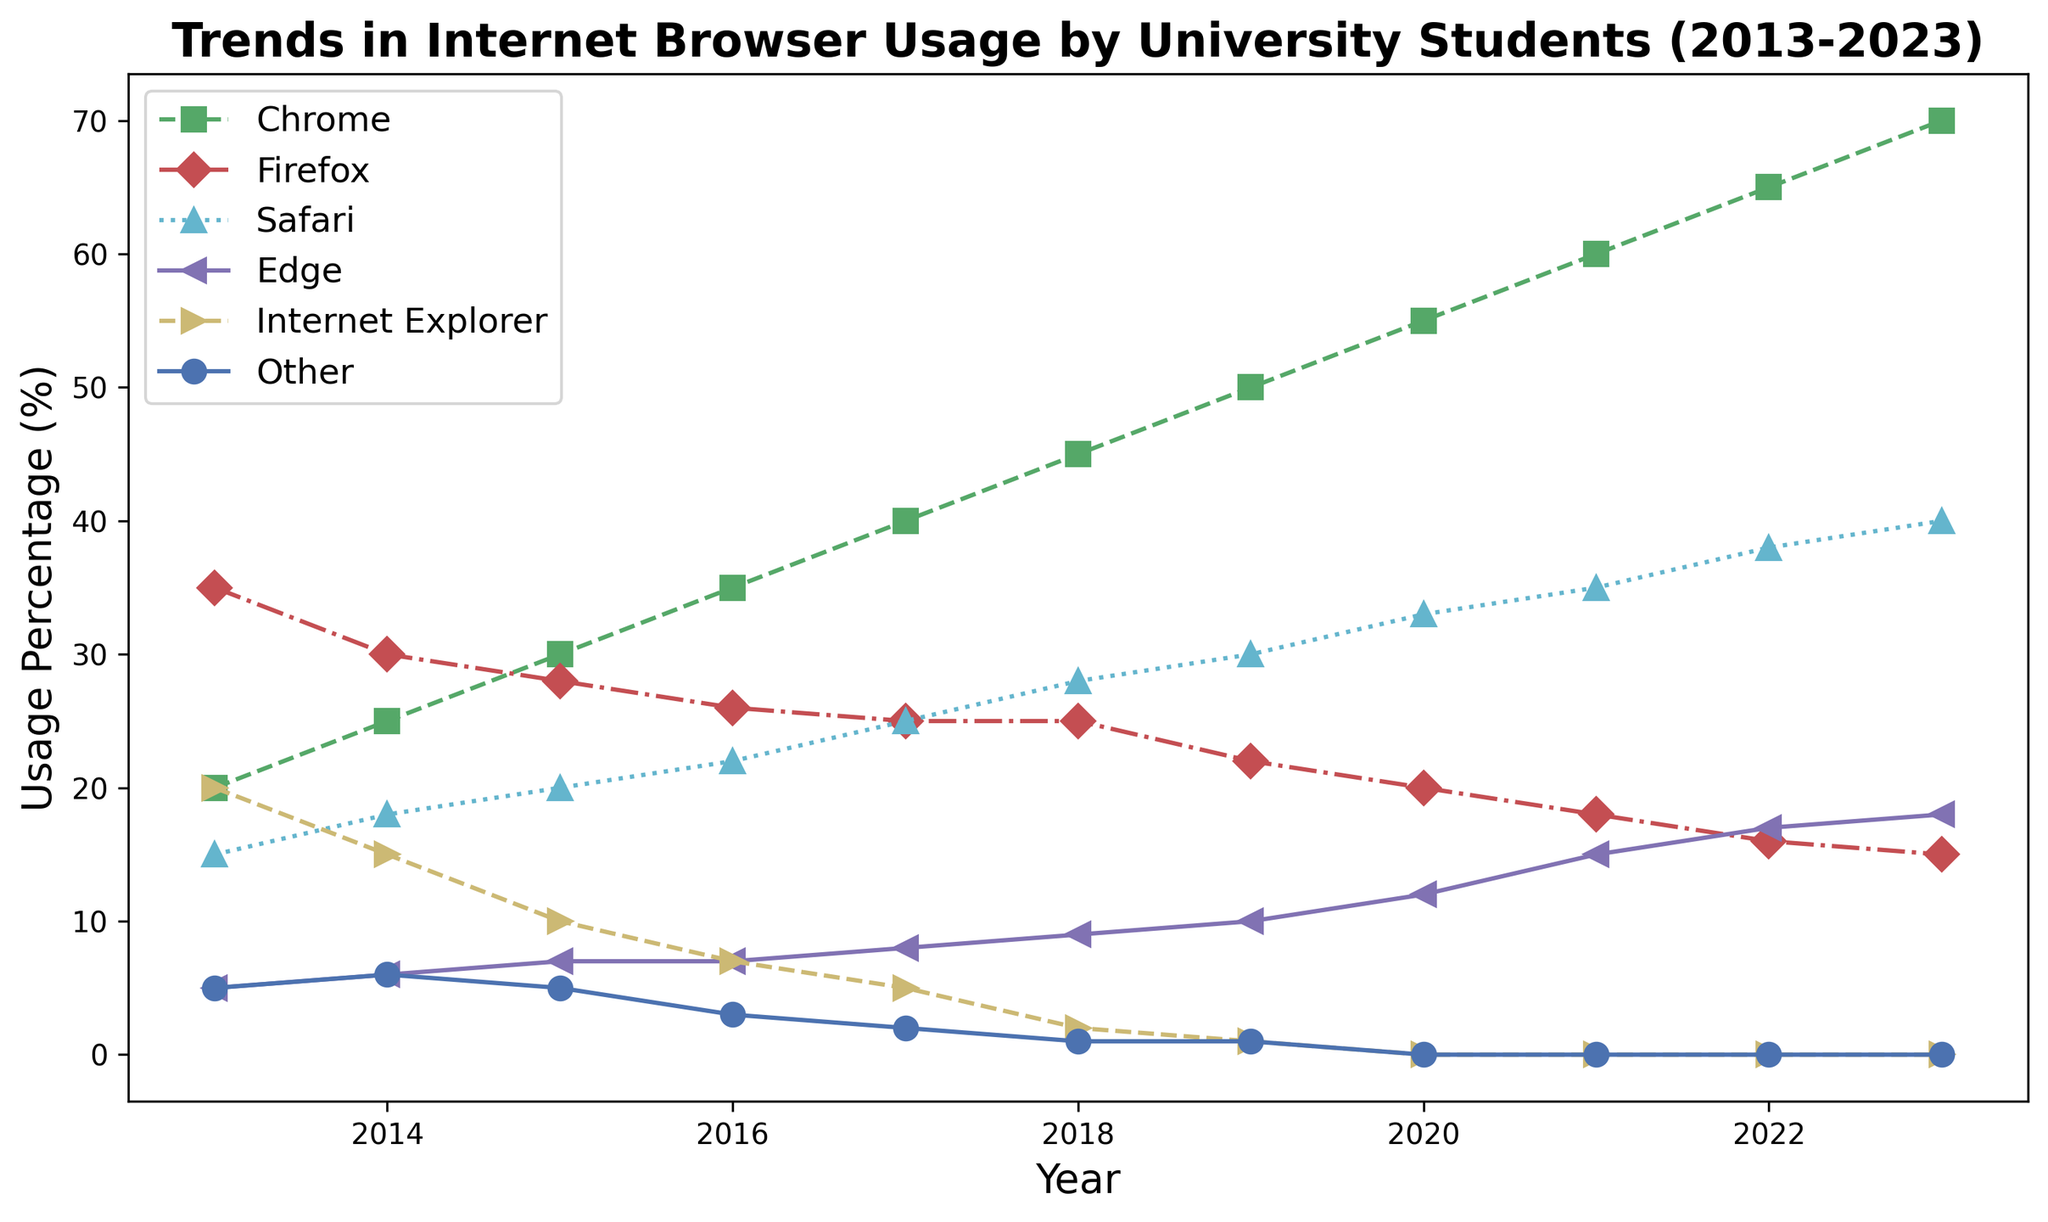What is the general trend of Chrome usage over the last decade? From the plot, we can see that Chrome usage has increased steadily from 20% in 2013 to 70% in 2023.
Answer: Increasing Which browser showed a decreasing trend and eventually reached 0% usage by 2020? Looking at the plotted lines, Internet Explorer shows a consistent decrease from 20% in 2013 to 0% by 2020.
Answer: Internet Explorer What year did Safari start to be used more than Firefox? By inspecting where the lines for Safari and Firefox cross, it can be seen that Safari usage surpasses Firefox's in 2017.
Answer: 2017 By how much did Edge's usage percentage increase from 2013 to 2023? In 2013, Edge was at 5%. By 2023, it increased to 18%. The difference is 18% - 5% = 13%.
Answer: 13% What is the trend of "Other" category browsers from 2013 to 2023? The "Other" category shows a declining trend, starting at 5% in 2013 and dropping to 0% by 2020.
Answer: Decreasing How much did the Firefox usage drop from its peak to its lowest point? Firefox peaked at 35% in 2013 and dropped to 15% in 2023. The decrease is 35% - 15% = 20%.
Answer: 20% What year did Edge's usage percentage surpass Internet Explorer's? Examining the plot for where Edge's line crosses Internet Explorer's, it occurs between 2017 and 2018. Thus, by 2018, Edge's usage surpassed Internet Explorer's.
Answer: 2018 Which browser had the most significant rise in usage over the decade and what is the approximate rate of increase per year? Chrome had the most significant rise, increasing from 20% in 2013 to 70% in 2023. Over ten years, the average yearly increase is (70% - 20%) / 10 = 5% per year.
Answer: Chrome, 5% per year Between which two years did Safari see its most significant yearly increase? Observing the sharpest ascent of Safari's line, the largest increase appears between 2017 (25%) and 2018 (28%). The increase is 28% - 25% = 3%.
Answer: 2017 and 2018 Which browser had nearly constant usage from 2013 to 2023, and what was the percentage range? Firefox had nearly constant usage, fluctuating between 35% and 15%, without substantial changes.
Answer: Firefox, 35%-15% 